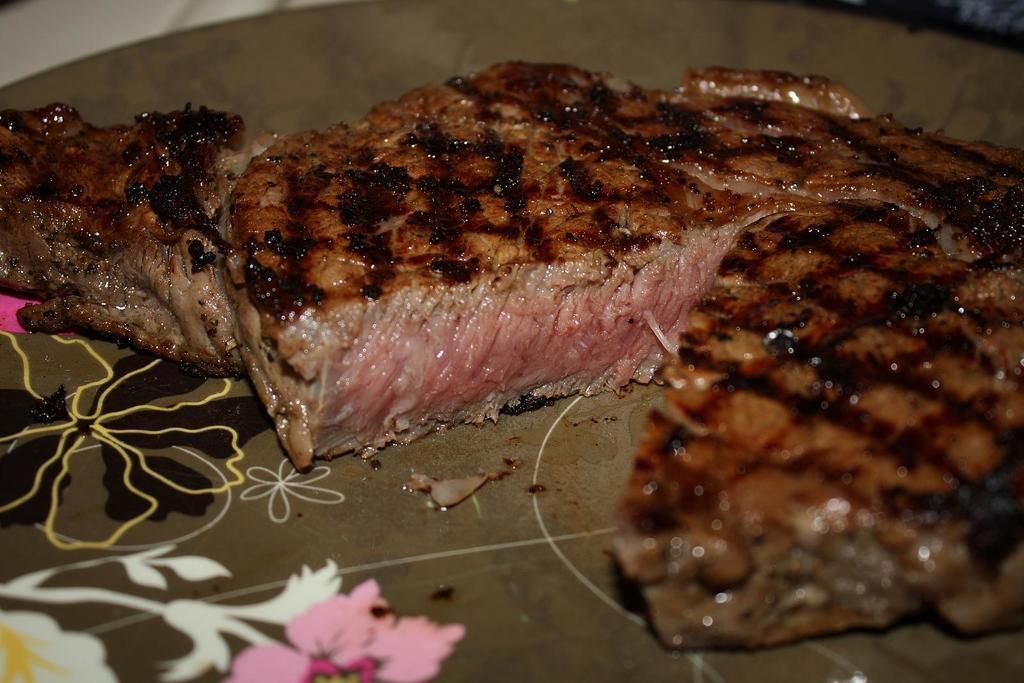What type of food is on the plate in the image? There is meat on a plate in the image. What type of nail is being used to hold the leather on the gate in the image? There is no nail, leather, or gate present in the image. 